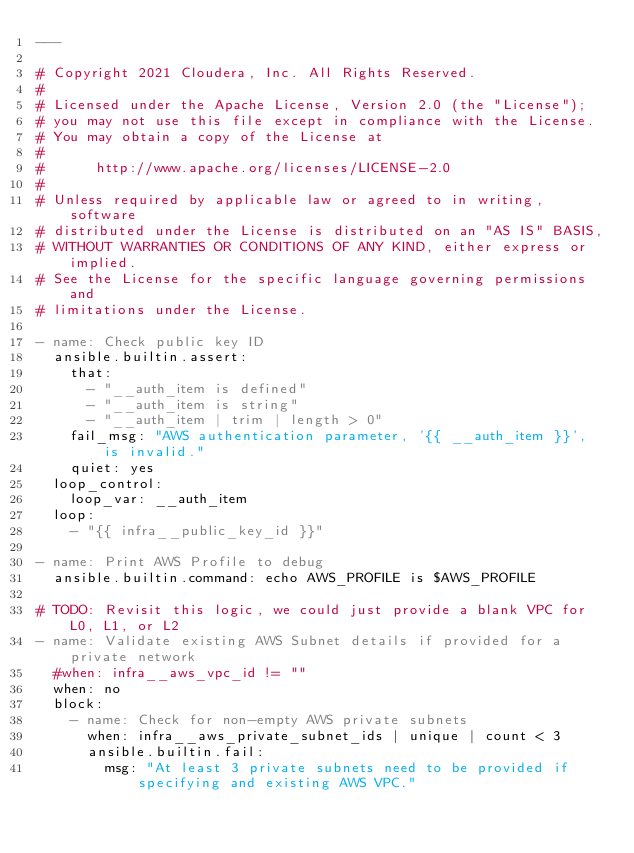Convert code to text. <code><loc_0><loc_0><loc_500><loc_500><_YAML_>---

# Copyright 2021 Cloudera, Inc. All Rights Reserved.
#
# Licensed under the Apache License, Version 2.0 (the "License");
# you may not use this file except in compliance with the License.
# You may obtain a copy of the License at
#
#      http://www.apache.org/licenses/LICENSE-2.0
#
# Unless required by applicable law or agreed to in writing, software
# distributed under the License is distributed on an "AS IS" BASIS,
# WITHOUT WARRANTIES OR CONDITIONS OF ANY KIND, either express or implied.
# See the License for the specific language governing permissions and
# limitations under the License.

- name: Check public key ID
  ansible.builtin.assert:
    that: 
      - "__auth_item is defined"
      - "__auth_item is string"
      - "__auth_item | trim | length > 0"
    fail_msg: "AWS authentication parameter, '{{ __auth_item }}', is invalid."
    quiet: yes
  loop_control:
    loop_var: __auth_item
  loop:
    - "{{ infra__public_key_id }}"

- name: Print AWS Profile to debug
  ansible.builtin.command: echo AWS_PROFILE is $AWS_PROFILE

# TODO: Revisit this logic, we could just provide a blank VPC for L0, L1, or L2
- name: Validate existing AWS Subnet details if provided for a private network
  #when: infra__aws_vpc_id != "" 
  when: no
  block:
    - name: Check for non-empty AWS private subnets
      when: infra__aws_private_subnet_ids | unique | count < 3
      ansible.builtin.fail:
        msg: "At least 3 private subnets need to be provided if specifying and existing AWS VPC."</code> 